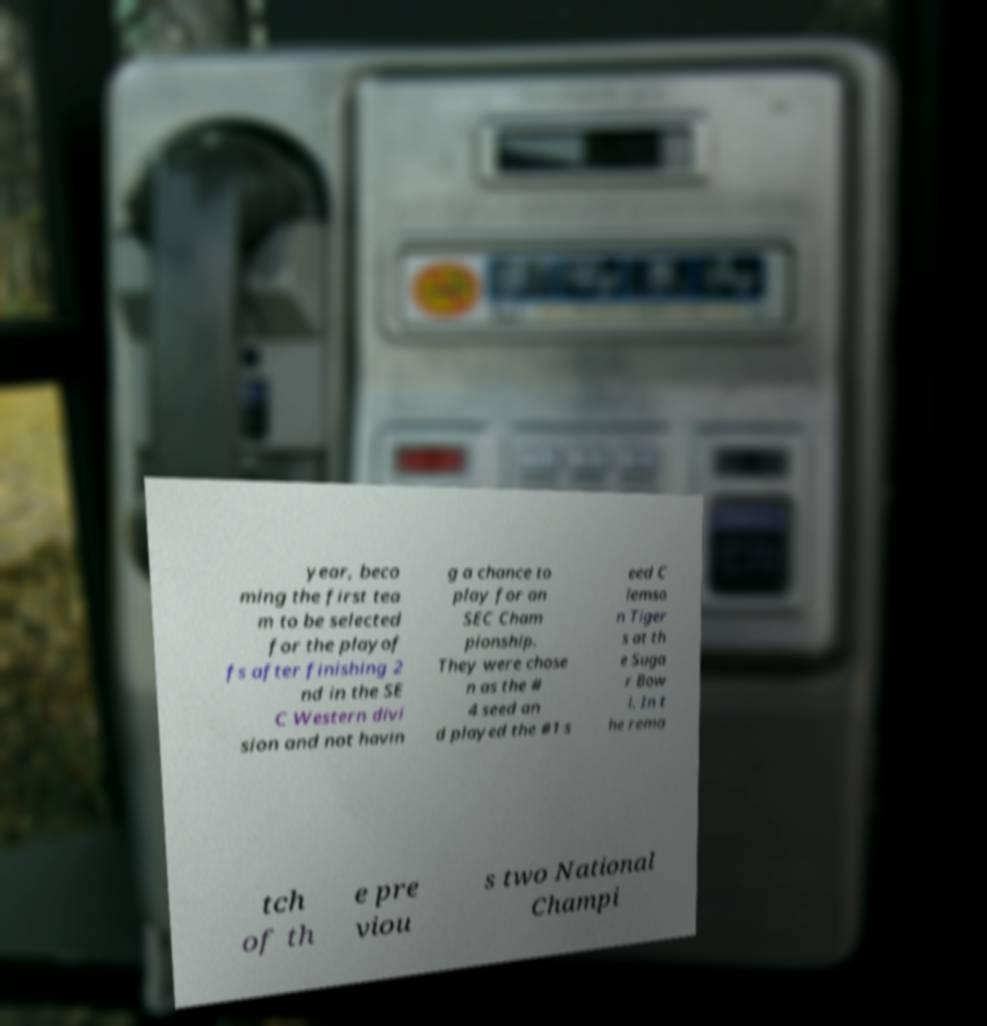Please identify and transcribe the text found in this image. year, beco ming the first tea m to be selected for the playof fs after finishing 2 nd in the SE C Western divi sion and not havin g a chance to play for an SEC Cham pionship. They were chose n as the # 4 seed an d played the #1 s eed C lemso n Tiger s at th e Suga r Bow l. In t he rema tch of th e pre viou s two National Champi 